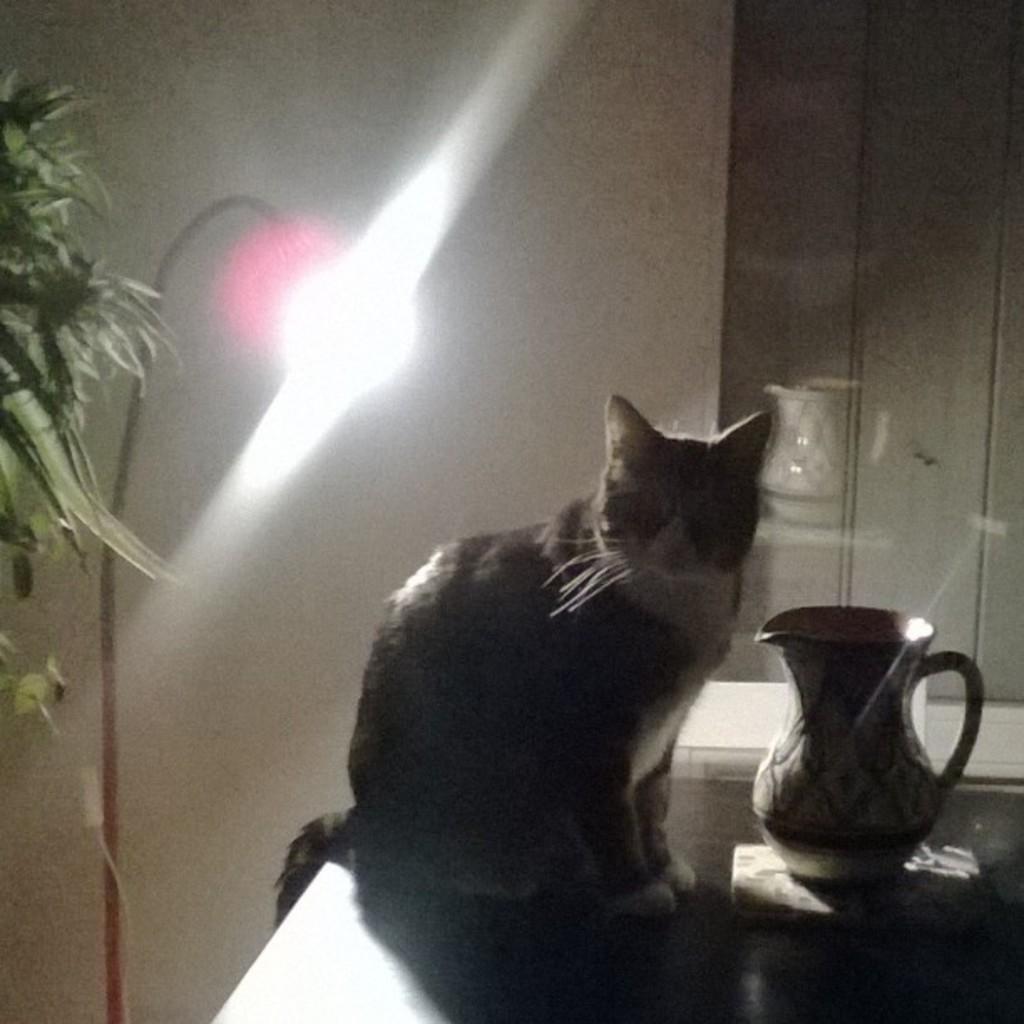Please provide a concise description of this image. In the image we can see there is a cat sitting on the table and there is jug kept on the table. Behind there is a plant and there is a white colour wall. There is a jug kept on the table. 